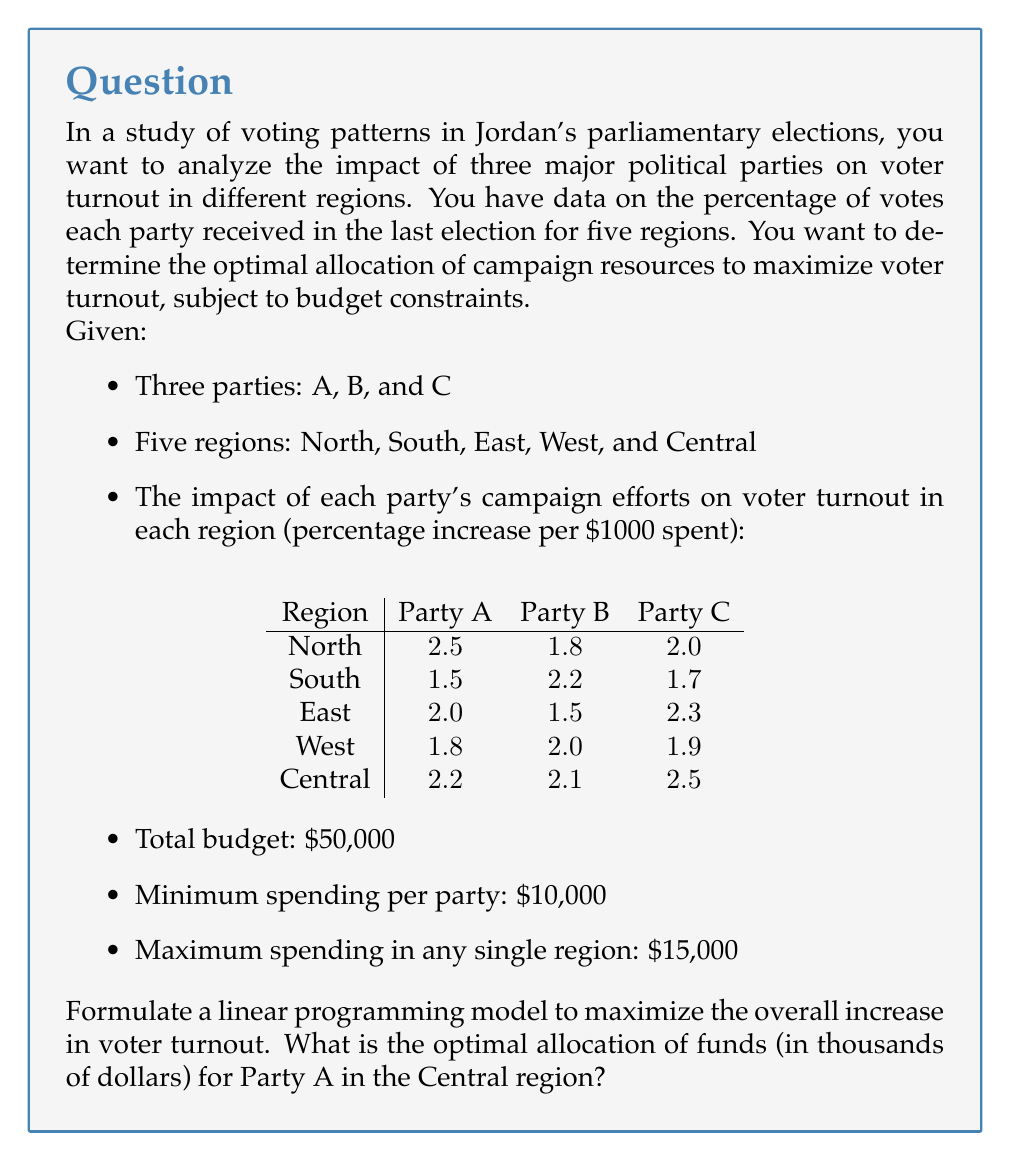Provide a solution to this math problem. To solve this problem, we need to formulate a linear programming model and then solve it. Let's break it down step by step:

1. Define decision variables:
   Let $x_{ij}$ be the amount (in thousands of dollars) spent by party $i$ in region $j$
   where $i \in \{A, B, C\}$ and $j \in \{N, S, E, W, C\}$

2. Objective function:
   Maximize total voter turnout increase:
   $$\text{Max } Z = 2.5x_{AN} + 1.8x_{BN} + 2.0x_{CN} + 1.5x_{AS} + 2.2x_{BS} + 1.7x_{CS} + 2.0x_{AE} + 1.5x_{BE} + 2.3x_{CE} + 1.8x_{AW} + 2.0x_{BW} + 1.9x_{CW} + 2.2x_{AC} + 2.1x_{BC} + 2.5x_{CC}$$

3. Constraints:
   a) Total budget constraint:
      $$\sum_{i \in \{A,B,C\}} \sum_{j \in \{N,S,E,W,C\}} x_{ij} \leq 50$$

   b) Minimum spending per party:
      $$\sum_{j \in \{N,S,E,W,C\}} x_{Aj} \geq 10$$
      $$\sum_{j \in \{N,S,E,W,C\}} x_{Bj} \geq 10$$
      $$\sum_{j \in \{N,S,E,W,C\}} x_{Cj} \geq 10$$

   c) Maximum spending in any single region:
      $$x_{Aj} + x_{Bj} + x_{Cj} \leq 15 \text{ for all } j \in \{N,S,E,W,C\}$$

   d) Non-negativity constraints:
      $$x_{ij} \geq 0 \text{ for all } i \in \{A,B,C\} \text{ and } j \in \{N,S,E,W,C\}$$

4. Solve the linear programming model using a solver (e.g., simplex method or interior point method).

5. The optimal solution will provide the values for all $x_{ij}$. The question specifically asks for the optimal allocation for Party A in the Central region, which is represented by $x_{AC}$.
Answer: The optimal allocation for Party A in the Central region ($x_{AC}$) is $7.5$ thousand dollars or $7,500. 